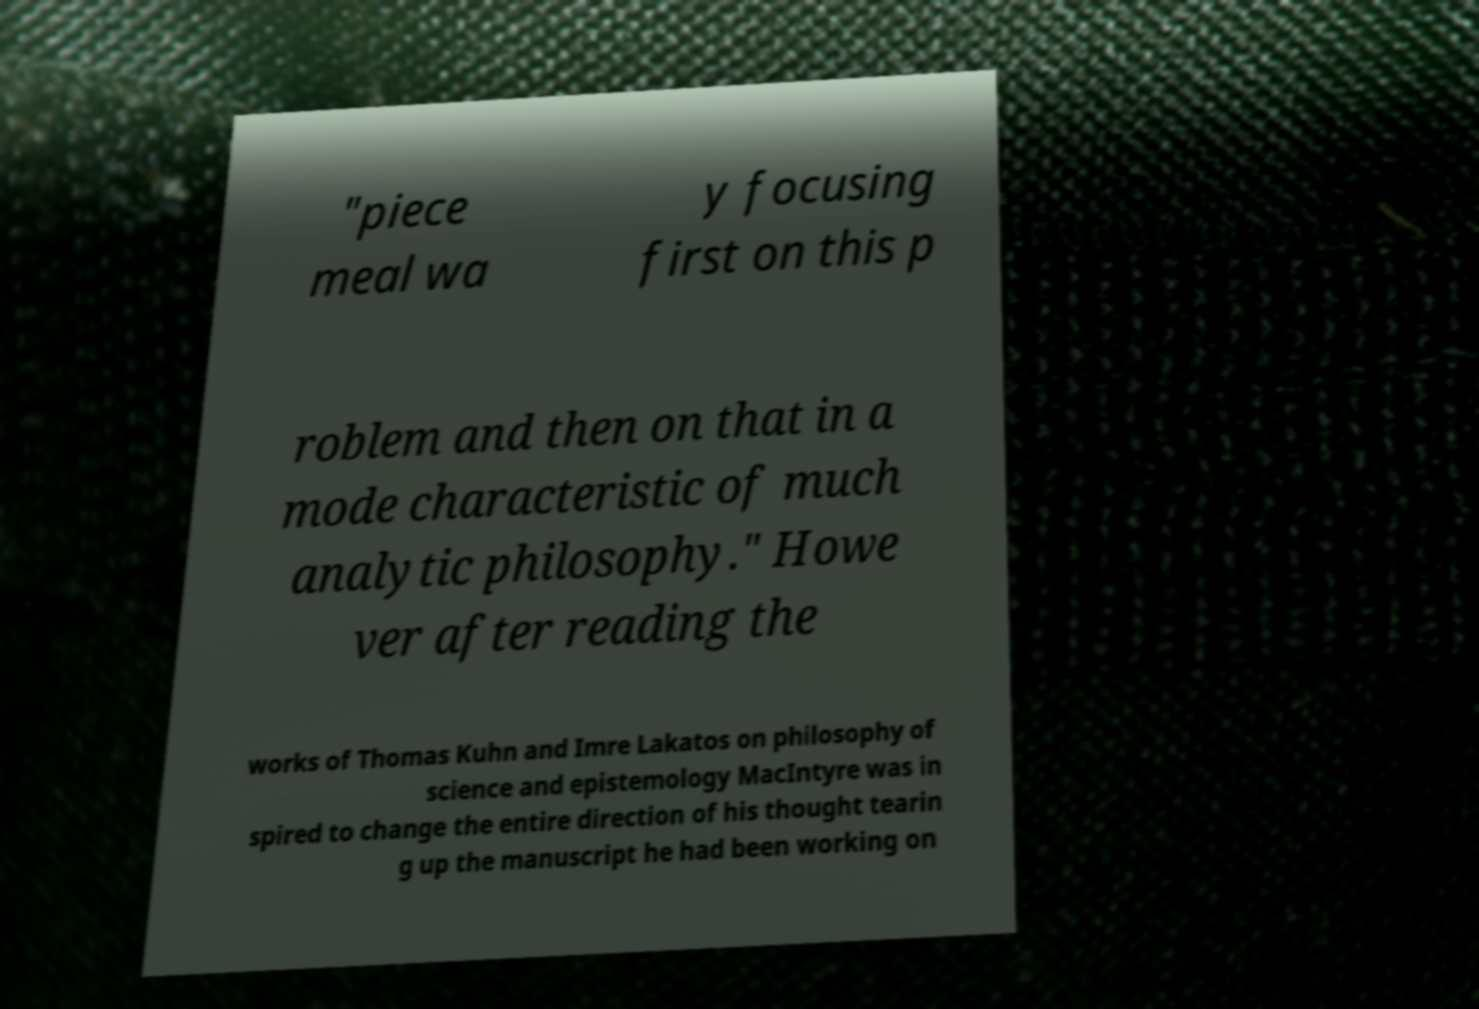I need the written content from this picture converted into text. Can you do that? "piece meal wa y focusing first on this p roblem and then on that in a mode characteristic of much analytic philosophy." Howe ver after reading the works of Thomas Kuhn and Imre Lakatos on philosophy of science and epistemology MacIntyre was in spired to change the entire direction of his thought tearin g up the manuscript he had been working on 